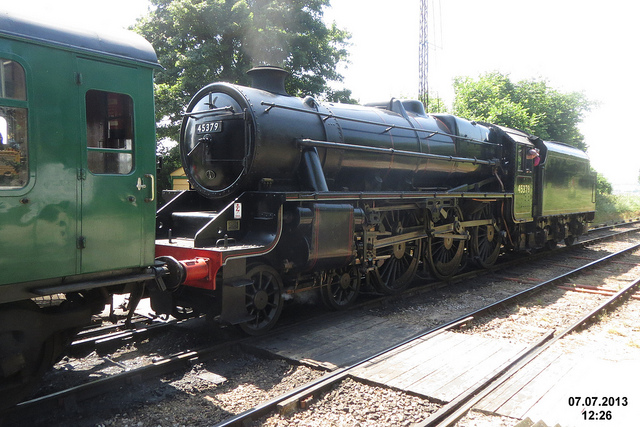What might have been the impact of trains like this on society at the time? Trains such as the one pictured revolutionized travel and trade. They significantly reduced travel time compared to horse-drawn carriages and made long-distance travel affordable for the masses. This democratization of travel fostered cultural exchange, economic growth, as various regions became interconnected. Moreover, the expansion of the railway network spurred industrial growth, enabling faster transport of raw materials and finished goods, stimulating economies and contributing to urbanization as more people migrated to cities for work. 